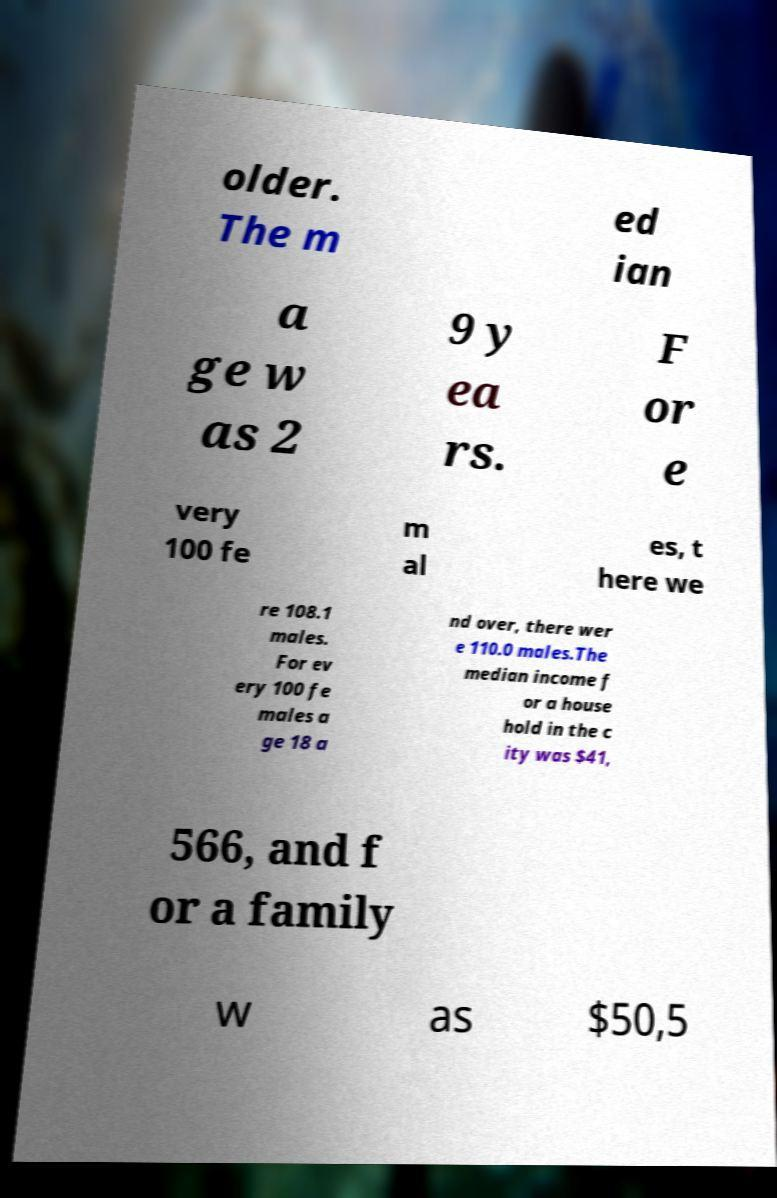What messages or text are displayed in this image? I need them in a readable, typed format. older. The m ed ian a ge w as 2 9 y ea rs. F or e very 100 fe m al es, t here we re 108.1 males. For ev ery 100 fe males a ge 18 a nd over, there wer e 110.0 males.The median income f or a house hold in the c ity was $41, 566, and f or a family w as $50,5 